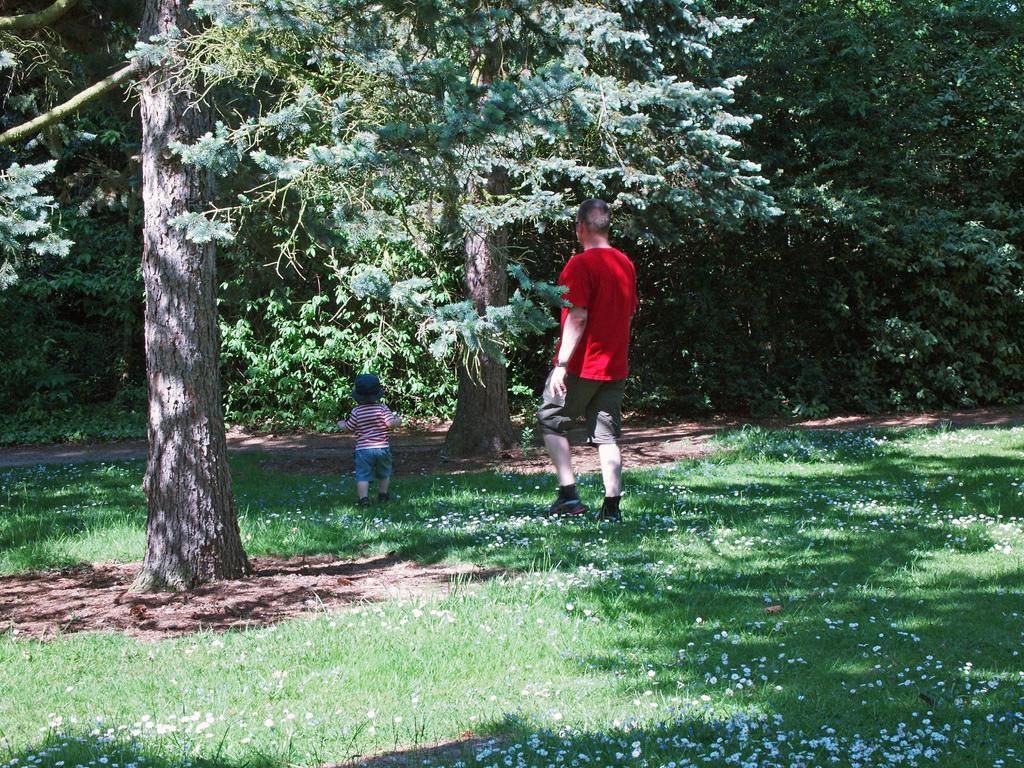In one or two sentences, can you explain what this image depicts? In the foreground of this picture, there is a man and a boy walking on the grass. In the background we can see grass, flowers and the trees. 